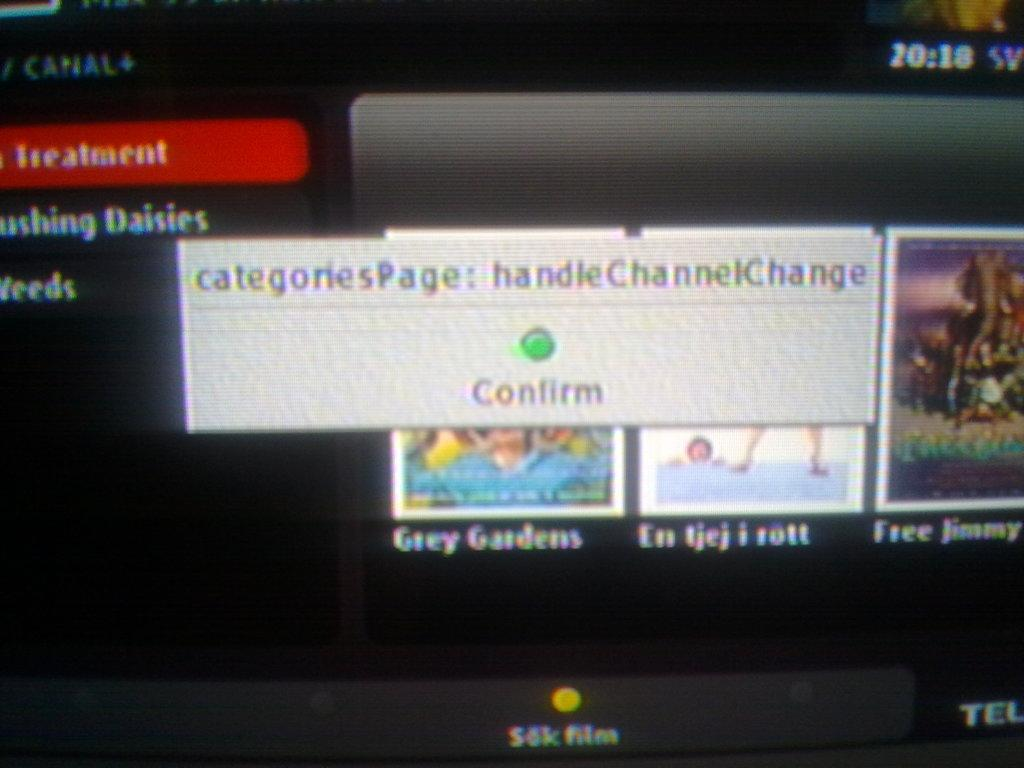<image>
Relay a brief, clear account of the picture shown. The message asks to confirm the categoriesPage: handleChannelChange. 